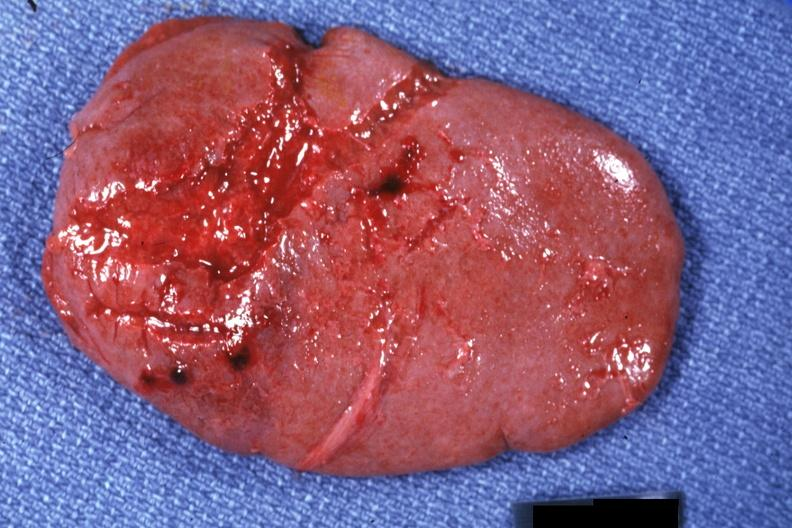s hematologic present?
Answer the question using a single word or phrase. Yes 